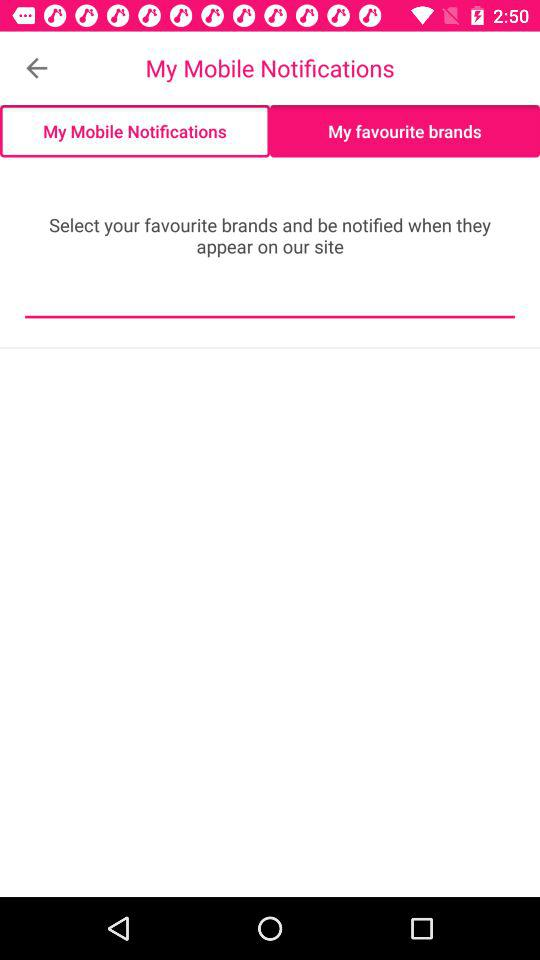What is the selected option? The selected option is "My favourite brands". 